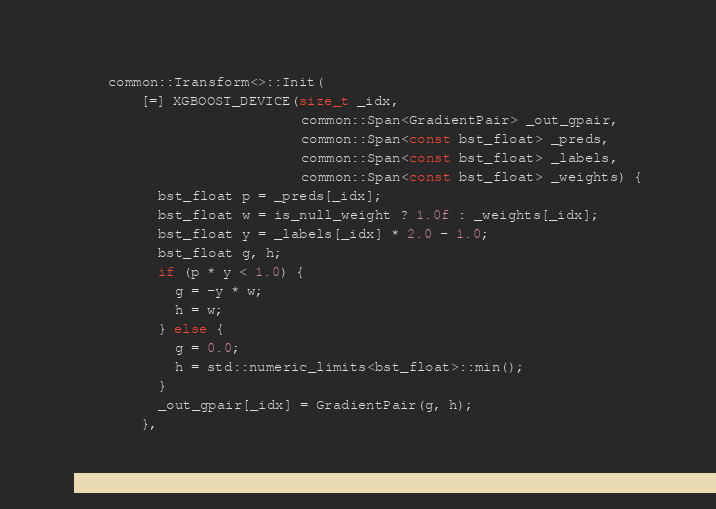<code> <loc_0><loc_0><loc_500><loc_500><_Cuda_>    common::Transform<>::Init(
        [=] XGBOOST_DEVICE(size_t _idx,
                           common::Span<GradientPair> _out_gpair,
                           common::Span<const bst_float> _preds,
                           common::Span<const bst_float> _labels,
                           common::Span<const bst_float> _weights) {
          bst_float p = _preds[_idx];
          bst_float w = is_null_weight ? 1.0f : _weights[_idx];
          bst_float y = _labels[_idx] * 2.0 - 1.0;
          bst_float g, h;
          if (p * y < 1.0) {
            g = -y * w;
            h = w;
          } else {
            g = 0.0;
            h = std::numeric_limits<bst_float>::min();
          }
          _out_gpair[_idx] = GradientPair(g, h);
        },</code> 